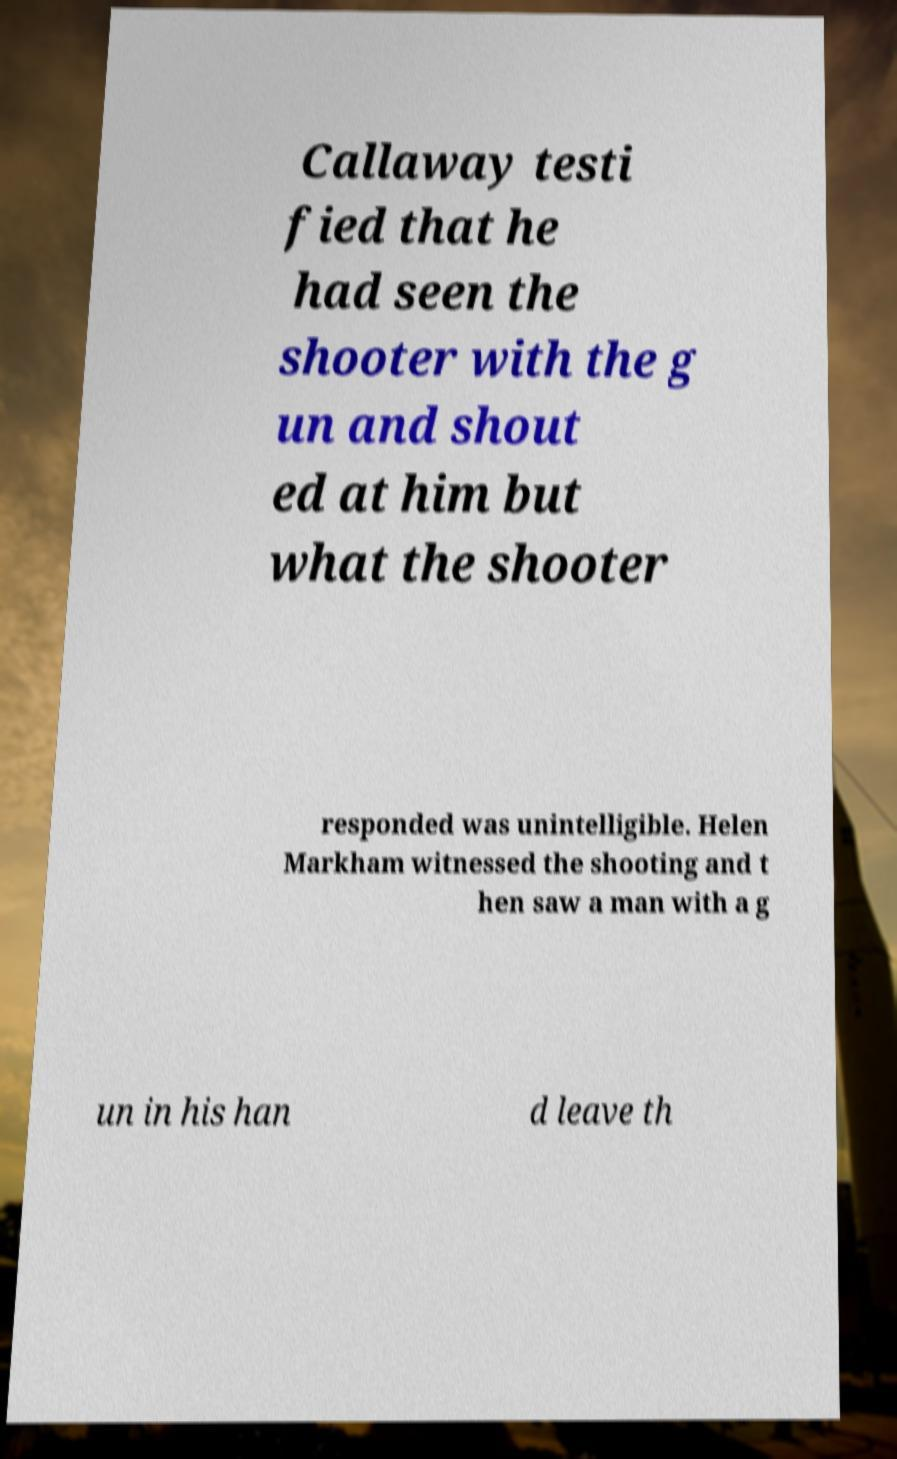Can you accurately transcribe the text from the provided image for me? Callaway testi fied that he had seen the shooter with the g un and shout ed at him but what the shooter responded was unintelligible. Helen Markham witnessed the shooting and t hen saw a man with a g un in his han d leave th 